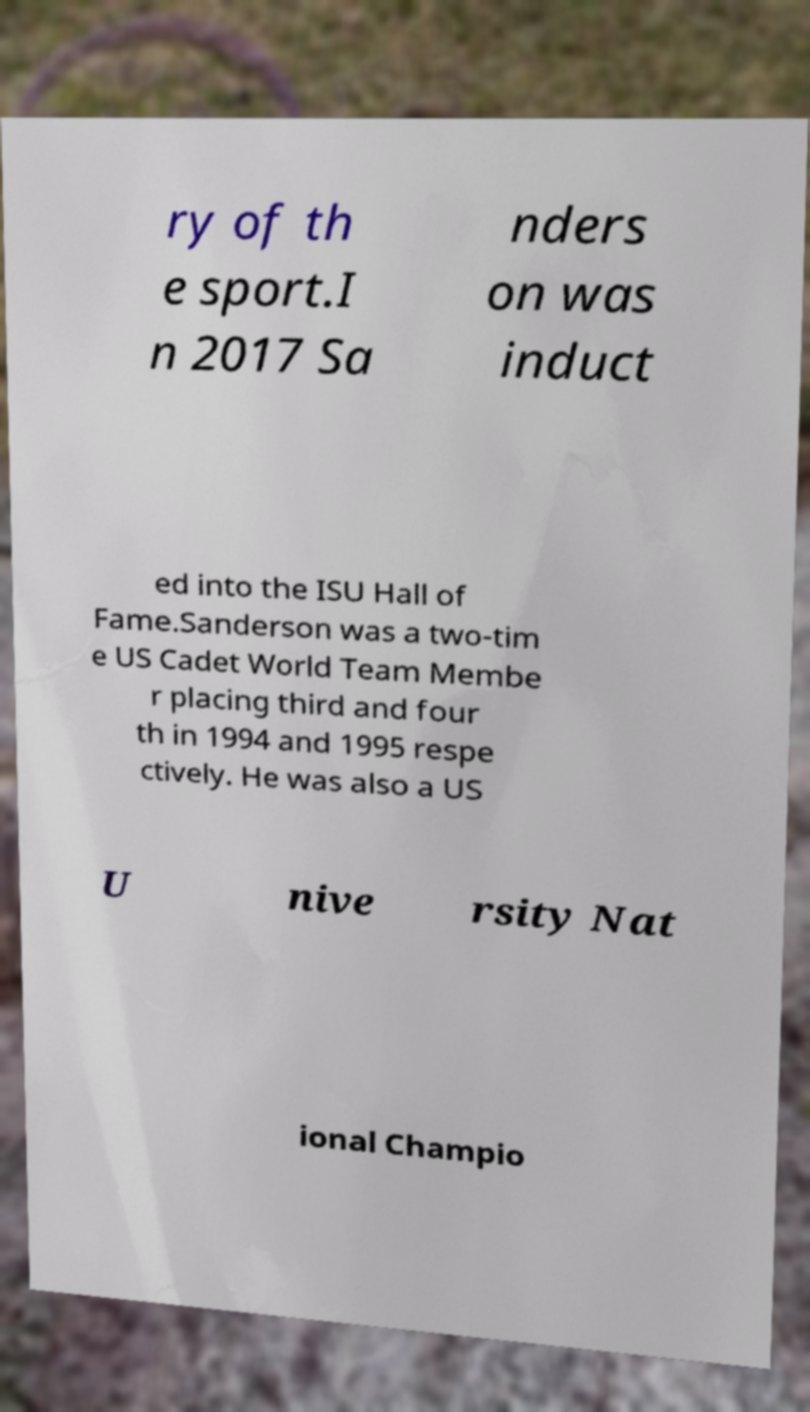For documentation purposes, I need the text within this image transcribed. Could you provide that? ry of th e sport.I n 2017 Sa nders on was induct ed into the ISU Hall of Fame.Sanderson was a two-tim e US Cadet World Team Membe r placing third and four th in 1994 and 1995 respe ctively. He was also a US U nive rsity Nat ional Champio 